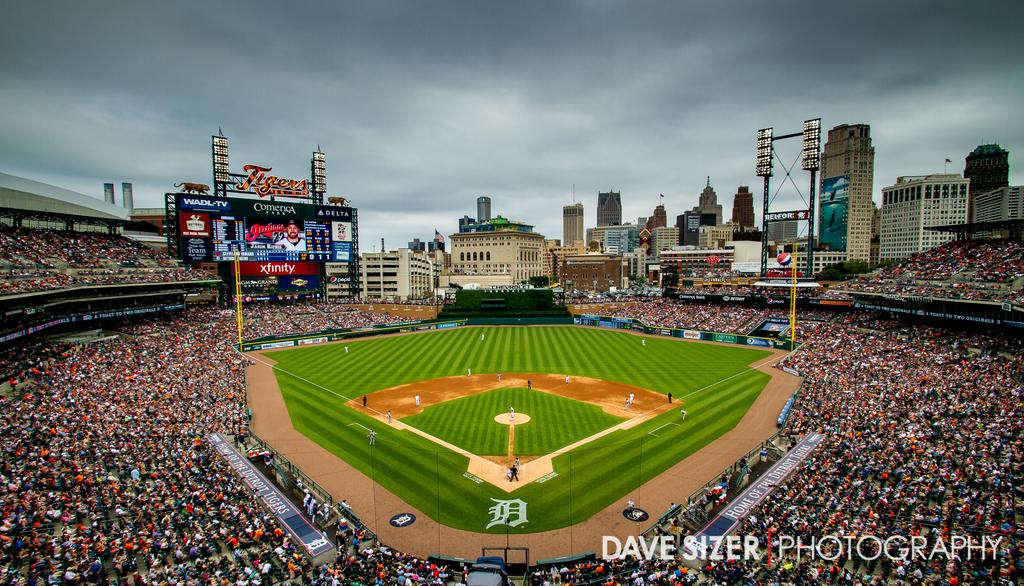<image>
Provide a brief description of the given image. A photo taken by the Dave Sizer company 